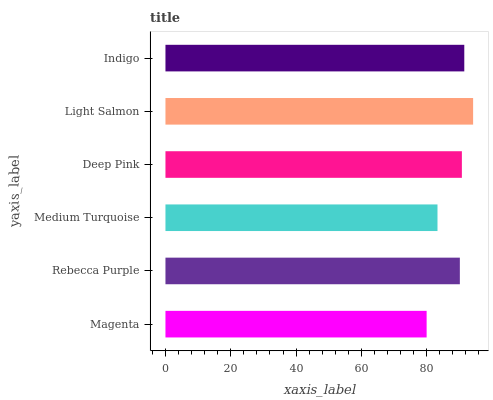Is Magenta the minimum?
Answer yes or no. Yes. Is Light Salmon the maximum?
Answer yes or no. Yes. Is Rebecca Purple the minimum?
Answer yes or no. No. Is Rebecca Purple the maximum?
Answer yes or no. No. Is Rebecca Purple greater than Magenta?
Answer yes or no. Yes. Is Magenta less than Rebecca Purple?
Answer yes or no. Yes. Is Magenta greater than Rebecca Purple?
Answer yes or no. No. Is Rebecca Purple less than Magenta?
Answer yes or no. No. Is Deep Pink the high median?
Answer yes or no. Yes. Is Rebecca Purple the low median?
Answer yes or no. Yes. Is Rebecca Purple the high median?
Answer yes or no. No. Is Medium Turquoise the low median?
Answer yes or no. No. 